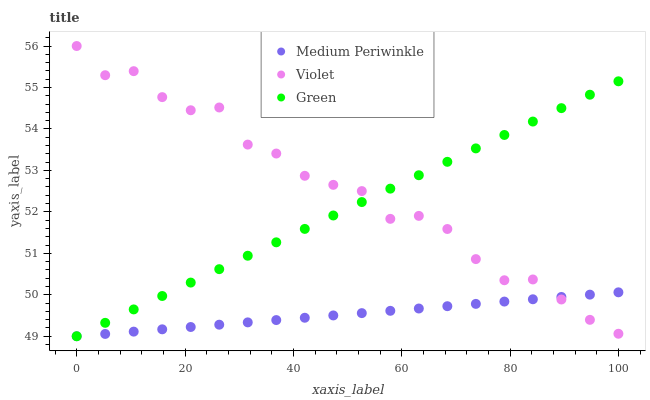Does Medium Periwinkle have the minimum area under the curve?
Answer yes or no. Yes. Does Violet have the maximum area under the curve?
Answer yes or no. Yes. Does Violet have the minimum area under the curve?
Answer yes or no. No. Does Medium Periwinkle have the maximum area under the curve?
Answer yes or no. No. Is Medium Periwinkle the smoothest?
Answer yes or no. Yes. Is Violet the roughest?
Answer yes or no. Yes. Is Violet the smoothest?
Answer yes or no. No. Is Medium Periwinkle the roughest?
Answer yes or no. No. Does Green have the lowest value?
Answer yes or no. Yes. Does Violet have the lowest value?
Answer yes or no. No. Does Violet have the highest value?
Answer yes or no. Yes. Does Medium Periwinkle have the highest value?
Answer yes or no. No. Does Green intersect Medium Periwinkle?
Answer yes or no. Yes. Is Green less than Medium Periwinkle?
Answer yes or no. No. Is Green greater than Medium Periwinkle?
Answer yes or no. No. 